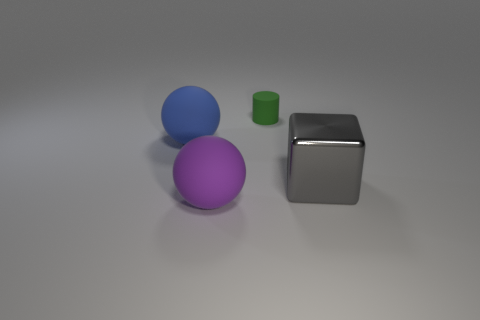Is the ball behind the purple matte sphere made of the same material as the block?
Offer a very short reply. No. How many large things are on the right side of the tiny green rubber cylinder and to the left of the big purple rubber object?
Offer a terse response. 0. There is a matte object that is to the right of the sphere in front of the blue rubber object; how big is it?
Your answer should be compact. Small. Is there any other thing that is the same material as the large cube?
Provide a short and direct response. No. Is the number of tiny brown objects greater than the number of gray metallic cubes?
Your answer should be compact. No. There is a large matte ball that is behind the purple matte thing; are there any things to the right of it?
Give a very brief answer. Yes. Is the number of matte cylinders on the right side of the big gray shiny thing less than the number of big purple objects to the left of the blue object?
Your answer should be very brief. No. Is the material of the object that is to the left of the purple ball the same as the large object right of the small green cylinder?
Your answer should be very brief. No. How many small things are gray metallic blocks or balls?
Give a very brief answer. 0. There is a tiny green thing that is made of the same material as the blue sphere; what shape is it?
Give a very brief answer. Cylinder. 